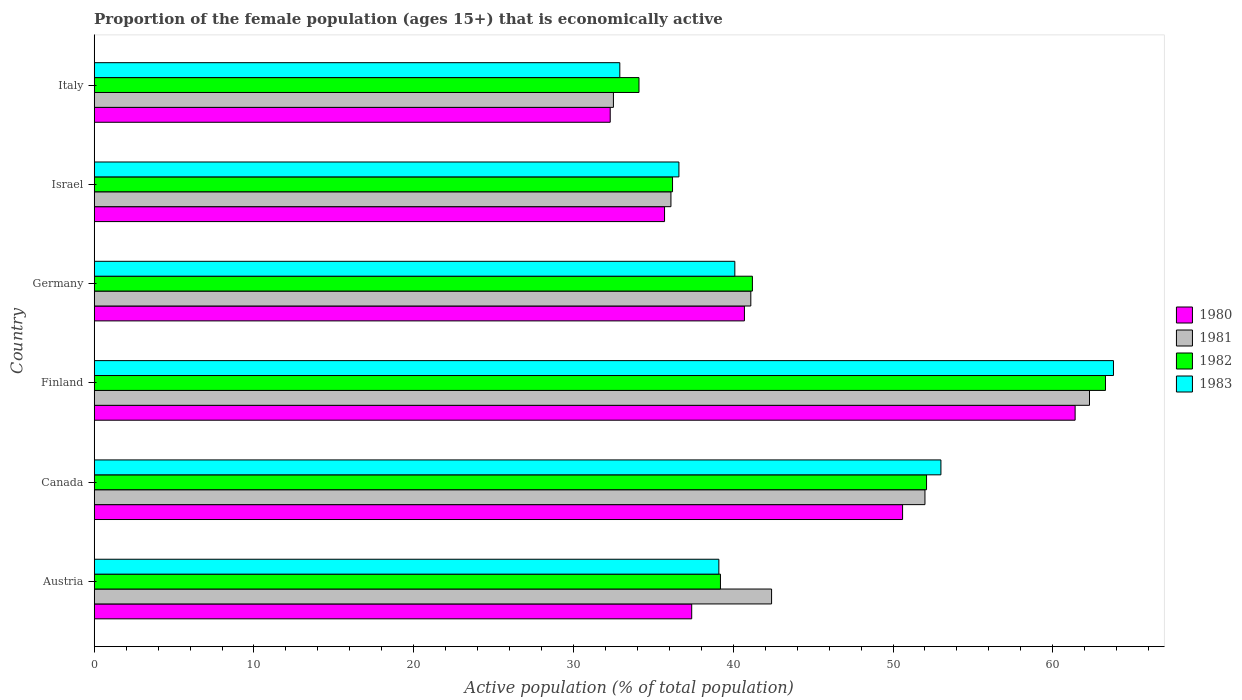How many different coloured bars are there?
Offer a terse response. 4. Are the number of bars per tick equal to the number of legend labels?
Offer a very short reply. Yes. How many bars are there on the 6th tick from the top?
Offer a terse response. 4. How many bars are there on the 6th tick from the bottom?
Your response must be concise. 4. What is the proportion of the female population that is economically active in 1981 in Israel?
Provide a short and direct response. 36.1. Across all countries, what is the maximum proportion of the female population that is economically active in 1983?
Your answer should be very brief. 63.8. Across all countries, what is the minimum proportion of the female population that is economically active in 1983?
Offer a terse response. 32.9. In which country was the proportion of the female population that is economically active in 1982 maximum?
Make the answer very short. Finland. In which country was the proportion of the female population that is economically active in 1982 minimum?
Ensure brevity in your answer.  Italy. What is the total proportion of the female population that is economically active in 1980 in the graph?
Give a very brief answer. 258.1. What is the difference between the proportion of the female population that is economically active in 1980 in Finland and that in Italy?
Ensure brevity in your answer.  29.1. What is the average proportion of the female population that is economically active in 1981 per country?
Your answer should be compact. 44.4. What is the difference between the proportion of the female population that is economically active in 1980 and proportion of the female population that is economically active in 1983 in Germany?
Your response must be concise. 0.6. What is the ratio of the proportion of the female population that is economically active in 1981 in Canada to that in Germany?
Provide a short and direct response. 1.27. What is the difference between the highest and the second highest proportion of the female population that is economically active in 1980?
Provide a succinct answer. 10.8. What is the difference between the highest and the lowest proportion of the female population that is economically active in 1980?
Offer a terse response. 29.1. Is the sum of the proportion of the female population that is economically active in 1983 in Austria and Germany greater than the maximum proportion of the female population that is economically active in 1981 across all countries?
Provide a short and direct response. Yes. Is it the case that in every country, the sum of the proportion of the female population that is economically active in 1981 and proportion of the female population that is economically active in 1983 is greater than the sum of proportion of the female population that is economically active in 1982 and proportion of the female population that is economically active in 1980?
Offer a terse response. No. What does the 3rd bar from the top in Israel represents?
Your response must be concise. 1981. What is the difference between two consecutive major ticks on the X-axis?
Keep it short and to the point. 10. Does the graph contain any zero values?
Provide a succinct answer. No. Where does the legend appear in the graph?
Ensure brevity in your answer.  Center right. How many legend labels are there?
Your answer should be very brief. 4. How are the legend labels stacked?
Your response must be concise. Vertical. What is the title of the graph?
Provide a succinct answer. Proportion of the female population (ages 15+) that is economically active. Does "1976" appear as one of the legend labels in the graph?
Offer a very short reply. No. What is the label or title of the X-axis?
Offer a terse response. Active population (% of total population). What is the Active population (% of total population) of 1980 in Austria?
Give a very brief answer. 37.4. What is the Active population (% of total population) in 1981 in Austria?
Offer a very short reply. 42.4. What is the Active population (% of total population) of 1982 in Austria?
Your answer should be very brief. 39.2. What is the Active population (% of total population) of 1983 in Austria?
Your response must be concise. 39.1. What is the Active population (% of total population) of 1980 in Canada?
Your answer should be very brief. 50.6. What is the Active population (% of total population) of 1982 in Canada?
Your response must be concise. 52.1. What is the Active population (% of total population) of 1980 in Finland?
Your response must be concise. 61.4. What is the Active population (% of total population) in 1981 in Finland?
Offer a terse response. 62.3. What is the Active population (% of total population) of 1982 in Finland?
Your answer should be very brief. 63.3. What is the Active population (% of total population) in 1983 in Finland?
Give a very brief answer. 63.8. What is the Active population (% of total population) of 1980 in Germany?
Offer a very short reply. 40.7. What is the Active population (% of total population) of 1981 in Germany?
Keep it short and to the point. 41.1. What is the Active population (% of total population) of 1982 in Germany?
Give a very brief answer. 41.2. What is the Active population (% of total population) in 1983 in Germany?
Offer a terse response. 40.1. What is the Active population (% of total population) in 1980 in Israel?
Provide a succinct answer. 35.7. What is the Active population (% of total population) of 1981 in Israel?
Give a very brief answer. 36.1. What is the Active population (% of total population) in 1982 in Israel?
Provide a succinct answer. 36.2. What is the Active population (% of total population) in 1983 in Israel?
Offer a terse response. 36.6. What is the Active population (% of total population) of 1980 in Italy?
Your answer should be very brief. 32.3. What is the Active population (% of total population) in 1981 in Italy?
Your answer should be compact. 32.5. What is the Active population (% of total population) in 1982 in Italy?
Provide a succinct answer. 34.1. What is the Active population (% of total population) in 1983 in Italy?
Offer a terse response. 32.9. Across all countries, what is the maximum Active population (% of total population) in 1980?
Give a very brief answer. 61.4. Across all countries, what is the maximum Active population (% of total population) of 1981?
Make the answer very short. 62.3. Across all countries, what is the maximum Active population (% of total population) of 1982?
Provide a succinct answer. 63.3. Across all countries, what is the maximum Active population (% of total population) in 1983?
Offer a terse response. 63.8. Across all countries, what is the minimum Active population (% of total population) in 1980?
Offer a terse response. 32.3. Across all countries, what is the minimum Active population (% of total population) of 1981?
Your response must be concise. 32.5. Across all countries, what is the minimum Active population (% of total population) of 1982?
Ensure brevity in your answer.  34.1. Across all countries, what is the minimum Active population (% of total population) in 1983?
Your answer should be compact. 32.9. What is the total Active population (% of total population) of 1980 in the graph?
Your answer should be compact. 258.1. What is the total Active population (% of total population) in 1981 in the graph?
Your answer should be very brief. 266.4. What is the total Active population (% of total population) in 1982 in the graph?
Your response must be concise. 266.1. What is the total Active population (% of total population) of 1983 in the graph?
Ensure brevity in your answer.  265.5. What is the difference between the Active population (% of total population) in 1981 in Austria and that in Canada?
Give a very brief answer. -9.6. What is the difference between the Active population (% of total population) of 1981 in Austria and that in Finland?
Your response must be concise. -19.9. What is the difference between the Active population (% of total population) in 1982 in Austria and that in Finland?
Your answer should be compact. -24.1. What is the difference between the Active population (% of total population) of 1983 in Austria and that in Finland?
Your response must be concise. -24.7. What is the difference between the Active population (% of total population) of 1980 in Austria and that in Israel?
Ensure brevity in your answer.  1.7. What is the difference between the Active population (% of total population) in 1983 in Austria and that in Israel?
Your answer should be compact. 2.5. What is the difference between the Active population (% of total population) in 1981 in Austria and that in Italy?
Ensure brevity in your answer.  9.9. What is the difference between the Active population (% of total population) of 1982 in Austria and that in Italy?
Provide a succinct answer. 5.1. What is the difference between the Active population (% of total population) in 1983 in Austria and that in Italy?
Offer a terse response. 6.2. What is the difference between the Active population (% of total population) of 1980 in Canada and that in Finland?
Provide a succinct answer. -10.8. What is the difference between the Active population (% of total population) in 1981 in Canada and that in Finland?
Provide a short and direct response. -10.3. What is the difference between the Active population (% of total population) in 1982 in Canada and that in Finland?
Provide a succinct answer. -11.2. What is the difference between the Active population (% of total population) of 1983 in Canada and that in Finland?
Ensure brevity in your answer.  -10.8. What is the difference between the Active population (% of total population) in 1982 in Canada and that in Germany?
Your answer should be very brief. 10.9. What is the difference between the Active population (% of total population) of 1980 in Canada and that in Israel?
Keep it short and to the point. 14.9. What is the difference between the Active population (% of total population) in 1983 in Canada and that in Israel?
Provide a succinct answer. 16.4. What is the difference between the Active population (% of total population) in 1980 in Canada and that in Italy?
Make the answer very short. 18.3. What is the difference between the Active population (% of total population) of 1982 in Canada and that in Italy?
Ensure brevity in your answer.  18. What is the difference between the Active population (% of total population) of 1983 in Canada and that in Italy?
Offer a terse response. 20.1. What is the difference between the Active population (% of total population) of 1980 in Finland and that in Germany?
Your answer should be compact. 20.7. What is the difference between the Active population (% of total population) in 1981 in Finland and that in Germany?
Offer a very short reply. 21.2. What is the difference between the Active population (% of total population) of 1982 in Finland and that in Germany?
Provide a succinct answer. 22.1. What is the difference between the Active population (% of total population) of 1983 in Finland and that in Germany?
Provide a succinct answer. 23.7. What is the difference between the Active population (% of total population) of 1980 in Finland and that in Israel?
Provide a short and direct response. 25.7. What is the difference between the Active population (% of total population) in 1981 in Finland and that in Israel?
Offer a very short reply. 26.2. What is the difference between the Active population (% of total population) of 1982 in Finland and that in Israel?
Ensure brevity in your answer.  27.1. What is the difference between the Active population (% of total population) in 1983 in Finland and that in Israel?
Provide a succinct answer. 27.2. What is the difference between the Active population (% of total population) in 1980 in Finland and that in Italy?
Your response must be concise. 29.1. What is the difference between the Active population (% of total population) of 1981 in Finland and that in Italy?
Offer a very short reply. 29.8. What is the difference between the Active population (% of total population) in 1982 in Finland and that in Italy?
Offer a very short reply. 29.2. What is the difference between the Active population (% of total population) in 1983 in Finland and that in Italy?
Make the answer very short. 30.9. What is the difference between the Active population (% of total population) in 1980 in Germany and that in Israel?
Your response must be concise. 5. What is the difference between the Active population (% of total population) of 1982 in Germany and that in Israel?
Ensure brevity in your answer.  5. What is the difference between the Active population (% of total population) in 1983 in Germany and that in Israel?
Provide a succinct answer. 3.5. What is the difference between the Active population (% of total population) of 1980 in Germany and that in Italy?
Your answer should be compact. 8.4. What is the difference between the Active population (% of total population) of 1981 in Germany and that in Italy?
Your answer should be very brief. 8.6. What is the difference between the Active population (% of total population) in 1983 in Germany and that in Italy?
Provide a succinct answer. 7.2. What is the difference between the Active population (% of total population) in 1980 in Israel and that in Italy?
Your answer should be very brief. 3.4. What is the difference between the Active population (% of total population) in 1982 in Israel and that in Italy?
Ensure brevity in your answer.  2.1. What is the difference between the Active population (% of total population) of 1980 in Austria and the Active population (% of total population) of 1981 in Canada?
Your response must be concise. -14.6. What is the difference between the Active population (% of total population) of 1980 in Austria and the Active population (% of total population) of 1982 in Canada?
Offer a very short reply. -14.7. What is the difference between the Active population (% of total population) of 1980 in Austria and the Active population (% of total population) of 1983 in Canada?
Your answer should be very brief. -15.6. What is the difference between the Active population (% of total population) in 1981 in Austria and the Active population (% of total population) in 1983 in Canada?
Provide a succinct answer. -10.6. What is the difference between the Active population (% of total population) of 1982 in Austria and the Active population (% of total population) of 1983 in Canada?
Offer a very short reply. -13.8. What is the difference between the Active population (% of total population) in 1980 in Austria and the Active population (% of total population) in 1981 in Finland?
Offer a very short reply. -24.9. What is the difference between the Active population (% of total population) of 1980 in Austria and the Active population (% of total population) of 1982 in Finland?
Offer a terse response. -25.9. What is the difference between the Active population (% of total population) in 1980 in Austria and the Active population (% of total population) in 1983 in Finland?
Provide a short and direct response. -26.4. What is the difference between the Active population (% of total population) in 1981 in Austria and the Active population (% of total population) in 1982 in Finland?
Provide a succinct answer. -20.9. What is the difference between the Active population (% of total population) of 1981 in Austria and the Active population (% of total population) of 1983 in Finland?
Keep it short and to the point. -21.4. What is the difference between the Active population (% of total population) of 1982 in Austria and the Active population (% of total population) of 1983 in Finland?
Your answer should be compact. -24.6. What is the difference between the Active population (% of total population) in 1980 in Austria and the Active population (% of total population) in 1982 in Germany?
Keep it short and to the point. -3.8. What is the difference between the Active population (% of total population) in 1981 in Austria and the Active population (% of total population) in 1982 in Germany?
Give a very brief answer. 1.2. What is the difference between the Active population (% of total population) in 1980 in Austria and the Active population (% of total population) in 1981 in Israel?
Give a very brief answer. 1.3. What is the difference between the Active population (% of total population) in 1980 in Austria and the Active population (% of total population) in 1983 in Israel?
Keep it short and to the point. 0.8. What is the difference between the Active population (% of total population) in 1981 in Austria and the Active population (% of total population) in 1982 in Israel?
Your response must be concise. 6.2. What is the difference between the Active population (% of total population) in 1982 in Austria and the Active population (% of total population) in 1983 in Israel?
Your answer should be compact. 2.6. What is the difference between the Active population (% of total population) in 1980 in Austria and the Active population (% of total population) in 1981 in Italy?
Provide a succinct answer. 4.9. What is the difference between the Active population (% of total population) of 1980 in Austria and the Active population (% of total population) of 1982 in Italy?
Ensure brevity in your answer.  3.3. What is the difference between the Active population (% of total population) of 1980 in Austria and the Active population (% of total population) of 1983 in Italy?
Provide a short and direct response. 4.5. What is the difference between the Active population (% of total population) of 1981 in Canada and the Active population (% of total population) of 1983 in Finland?
Make the answer very short. -11.8. What is the difference between the Active population (% of total population) of 1982 in Canada and the Active population (% of total population) of 1983 in Finland?
Give a very brief answer. -11.7. What is the difference between the Active population (% of total population) of 1980 in Canada and the Active population (% of total population) of 1981 in Germany?
Give a very brief answer. 9.5. What is the difference between the Active population (% of total population) in 1981 in Canada and the Active population (% of total population) in 1982 in Germany?
Your response must be concise. 10.8. What is the difference between the Active population (% of total population) in 1982 in Canada and the Active population (% of total population) in 1983 in Germany?
Your answer should be very brief. 12. What is the difference between the Active population (% of total population) of 1980 in Canada and the Active population (% of total population) of 1981 in Israel?
Keep it short and to the point. 14.5. What is the difference between the Active population (% of total population) of 1980 in Canada and the Active population (% of total population) of 1982 in Israel?
Offer a terse response. 14.4. What is the difference between the Active population (% of total population) of 1980 in Canada and the Active population (% of total population) of 1983 in Israel?
Make the answer very short. 14. What is the difference between the Active population (% of total population) in 1981 in Canada and the Active population (% of total population) in 1982 in Israel?
Give a very brief answer. 15.8. What is the difference between the Active population (% of total population) of 1982 in Canada and the Active population (% of total population) of 1983 in Israel?
Offer a very short reply. 15.5. What is the difference between the Active population (% of total population) of 1980 in Canada and the Active population (% of total population) of 1982 in Italy?
Your response must be concise. 16.5. What is the difference between the Active population (% of total population) in 1980 in Canada and the Active population (% of total population) in 1983 in Italy?
Keep it short and to the point. 17.7. What is the difference between the Active population (% of total population) in 1980 in Finland and the Active population (% of total population) in 1981 in Germany?
Your answer should be compact. 20.3. What is the difference between the Active population (% of total population) of 1980 in Finland and the Active population (% of total population) of 1982 in Germany?
Your answer should be compact. 20.2. What is the difference between the Active population (% of total population) of 1980 in Finland and the Active population (% of total population) of 1983 in Germany?
Your answer should be very brief. 21.3. What is the difference between the Active population (% of total population) of 1981 in Finland and the Active population (% of total population) of 1982 in Germany?
Provide a succinct answer. 21.1. What is the difference between the Active population (% of total population) in 1981 in Finland and the Active population (% of total population) in 1983 in Germany?
Make the answer very short. 22.2. What is the difference between the Active population (% of total population) of 1982 in Finland and the Active population (% of total population) of 1983 in Germany?
Make the answer very short. 23.2. What is the difference between the Active population (% of total population) of 1980 in Finland and the Active population (% of total population) of 1981 in Israel?
Give a very brief answer. 25.3. What is the difference between the Active population (% of total population) in 1980 in Finland and the Active population (% of total population) in 1982 in Israel?
Give a very brief answer. 25.2. What is the difference between the Active population (% of total population) of 1980 in Finland and the Active population (% of total population) of 1983 in Israel?
Provide a short and direct response. 24.8. What is the difference between the Active population (% of total population) of 1981 in Finland and the Active population (% of total population) of 1982 in Israel?
Provide a short and direct response. 26.1. What is the difference between the Active population (% of total population) of 1981 in Finland and the Active population (% of total population) of 1983 in Israel?
Keep it short and to the point. 25.7. What is the difference between the Active population (% of total population) of 1982 in Finland and the Active population (% of total population) of 1983 in Israel?
Ensure brevity in your answer.  26.7. What is the difference between the Active population (% of total population) of 1980 in Finland and the Active population (% of total population) of 1981 in Italy?
Keep it short and to the point. 28.9. What is the difference between the Active population (% of total population) in 1980 in Finland and the Active population (% of total population) in 1982 in Italy?
Provide a short and direct response. 27.3. What is the difference between the Active population (% of total population) in 1980 in Finland and the Active population (% of total population) in 1983 in Italy?
Your response must be concise. 28.5. What is the difference between the Active population (% of total population) in 1981 in Finland and the Active population (% of total population) in 1982 in Italy?
Ensure brevity in your answer.  28.2. What is the difference between the Active population (% of total population) in 1981 in Finland and the Active population (% of total population) in 1983 in Italy?
Your answer should be compact. 29.4. What is the difference between the Active population (% of total population) in 1982 in Finland and the Active population (% of total population) in 1983 in Italy?
Ensure brevity in your answer.  30.4. What is the difference between the Active population (% of total population) in 1980 in Germany and the Active population (% of total population) in 1983 in Israel?
Offer a terse response. 4.1. What is the difference between the Active population (% of total population) in 1981 in Germany and the Active population (% of total population) in 1983 in Israel?
Provide a short and direct response. 4.5. What is the difference between the Active population (% of total population) in 1982 in Germany and the Active population (% of total population) in 1983 in Israel?
Offer a terse response. 4.6. What is the difference between the Active population (% of total population) in 1980 in Germany and the Active population (% of total population) in 1981 in Italy?
Your answer should be compact. 8.2. What is the difference between the Active population (% of total population) in 1980 in Israel and the Active population (% of total population) in 1981 in Italy?
Provide a succinct answer. 3.2. What is the difference between the Active population (% of total population) of 1980 in Israel and the Active population (% of total population) of 1982 in Italy?
Your response must be concise. 1.6. What is the difference between the Active population (% of total population) in 1981 in Israel and the Active population (% of total population) in 1982 in Italy?
Provide a short and direct response. 2. What is the difference between the Active population (% of total population) of 1981 in Israel and the Active population (% of total population) of 1983 in Italy?
Your answer should be very brief. 3.2. What is the difference between the Active population (% of total population) in 1982 in Israel and the Active population (% of total population) in 1983 in Italy?
Your answer should be compact. 3.3. What is the average Active population (% of total population) in 1980 per country?
Your response must be concise. 43.02. What is the average Active population (% of total population) in 1981 per country?
Ensure brevity in your answer.  44.4. What is the average Active population (% of total population) in 1982 per country?
Your response must be concise. 44.35. What is the average Active population (% of total population) in 1983 per country?
Your answer should be compact. 44.25. What is the difference between the Active population (% of total population) of 1981 and Active population (% of total population) of 1983 in Austria?
Provide a succinct answer. 3.3. What is the difference between the Active population (% of total population) of 1981 and Active population (% of total population) of 1982 in Canada?
Provide a succinct answer. -0.1. What is the difference between the Active population (% of total population) of 1981 and Active population (% of total population) of 1983 in Canada?
Your response must be concise. -1. What is the difference between the Active population (% of total population) in 1980 and Active population (% of total population) in 1982 in Finland?
Your response must be concise. -1.9. What is the difference between the Active population (% of total population) in 1980 and Active population (% of total population) in 1983 in Finland?
Offer a very short reply. -2.4. What is the difference between the Active population (% of total population) of 1981 and Active population (% of total population) of 1982 in Finland?
Make the answer very short. -1. What is the difference between the Active population (% of total population) of 1981 and Active population (% of total population) of 1983 in Finland?
Provide a succinct answer. -1.5. What is the difference between the Active population (% of total population) of 1980 and Active population (% of total population) of 1981 in Germany?
Offer a terse response. -0.4. What is the difference between the Active population (% of total population) of 1980 and Active population (% of total population) of 1983 in Germany?
Make the answer very short. 0.6. What is the difference between the Active population (% of total population) of 1981 and Active population (% of total population) of 1982 in Germany?
Make the answer very short. -0.1. What is the difference between the Active population (% of total population) of 1980 and Active population (% of total population) of 1983 in Israel?
Ensure brevity in your answer.  -0.9. What is the difference between the Active population (% of total population) of 1981 and Active population (% of total population) of 1982 in Israel?
Give a very brief answer. -0.1. What is the difference between the Active population (% of total population) of 1981 and Active population (% of total population) of 1983 in Israel?
Keep it short and to the point. -0.5. What is the difference between the Active population (% of total population) in 1982 and Active population (% of total population) in 1983 in Israel?
Provide a succinct answer. -0.4. What is the difference between the Active population (% of total population) of 1980 and Active population (% of total population) of 1982 in Italy?
Give a very brief answer. -1.8. What is the difference between the Active population (% of total population) in 1981 and Active population (% of total population) in 1983 in Italy?
Your answer should be compact. -0.4. What is the difference between the Active population (% of total population) of 1982 and Active population (% of total population) of 1983 in Italy?
Provide a short and direct response. 1.2. What is the ratio of the Active population (% of total population) of 1980 in Austria to that in Canada?
Provide a short and direct response. 0.74. What is the ratio of the Active population (% of total population) in 1981 in Austria to that in Canada?
Provide a succinct answer. 0.82. What is the ratio of the Active population (% of total population) of 1982 in Austria to that in Canada?
Offer a terse response. 0.75. What is the ratio of the Active population (% of total population) in 1983 in Austria to that in Canada?
Ensure brevity in your answer.  0.74. What is the ratio of the Active population (% of total population) of 1980 in Austria to that in Finland?
Make the answer very short. 0.61. What is the ratio of the Active population (% of total population) of 1981 in Austria to that in Finland?
Your response must be concise. 0.68. What is the ratio of the Active population (% of total population) in 1982 in Austria to that in Finland?
Your answer should be very brief. 0.62. What is the ratio of the Active population (% of total population) in 1983 in Austria to that in Finland?
Provide a short and direct response. 0.61. What is the ratio of the Active population (% of total population) in 1980 in Austria to that in Germany?
Offer a terse response. 0.92. What is the ratio of the Active population (% of total population) of 1981 in Austria to that in Germany?
Your response must be concise. 1.03. What is the ratio of the Active population (% of total population) in 1982 in Austria to that in Germany?
Provide a short and direct response. 0.95. What is the ratio of the Active population (% of total population) of 1983 in Austria to that in Germany?
Your answer should be very brief. 0.98. What is the ratio of the Active population (% of total population) of 1980 in Austria to that in Israel?
Your answer should be very brief. 1.05. What is the ratio of the Active population (% of total population) in 1981 in Austria to that in Israel?
Offer a very short reply. 1.17. What is the ratio of the Active population (% of total population) of 1982 in Austria to that in Israel?
Your response must be concise. 1.08. What is the ratio of the Active population (% of total population) of 1983 in Austria to that in Israel?
Provide a succinct answer. 1.07. What is the ratio of the Active population (% of total population) in 1980 in Austria to that in Italy?
Offer a terse response. 1.16. What is the ratio of the Active population (% of total population) in 1981 in Austria to that in Italy?
Provide a short and direct response. 1.3. What is the ratio of the Active population (% of total population) in 1982 in Austria to that in Italy?
Provide a succinct answer. 1.15. What is the ratio of the Active population (% of total population) of 1983 in Austria to that in Italy?
Your answer should be compact. 1.19. What is the ratio of the Active population (% of total population) of 1980 in Canada to that in Finland?
Ensure brevity in your answer.  0.82. What is the ratio of the Active population (% of total population) of 1981 in Canada to that in Finland?
Your answer should be compact. 0.83. What is the ratio of the Active population (% of total population) in 1982 in Canada to that in Finland?
Your response must be concise. 0.82. What is the ratio of the Active population (% of total population) in 1983 in Canada to that in Finland?
Offer a terse response. 0.83. What is the ratio of the Active population (% of total population) in 1980 in Canada to that in Germany?
Provide a short and direct response. 1.24. What is the ratio of the Active population (% of total population) of 1981 in Canada to that in Germany?
Your answer should be compact. 1.27. What is the ratio of the Active population (% of total population) in 1982 in Canada to that in Germany?
Offer a very short reply. 1.26. What is the ratio of the Active population (% of total population) in 1983 in Canada to that in Germany?
Make the answer very short. 1.32. What is the ratio of the Active population (% of total population) of 1980 in Canada to that in Israel?
Keep it short and to the point. 1.42. What is the ratio of the Active population (% of total population) in 1981 in Canada to that in Israel?
Make the answer very short. 1.44. What is the ratio of the Active population (% of total population) of 1982 in Canada to that in Israel?
Your response must be concise. 1.44. What is the ratio of the Active population (% of total population) in 1983 in Canada to that in Israel?
Make the answer very short. 1.45. What is the ratio of the Active population (% of total population) of 1980 in Canada to that in Italy?
Provide a short and direct response. 1.57. What is the ratio of the Active population (% of total population) in 1981 in Canada to that in Italy?
Your answer should be compact. 1.6. What is the ratio of the Active population (% of total population) in 1982 in Canada to that in Italy?
Ensure brevity in your answer.  1.53. What is the ratio of the Active population (% of total population) of 1983 in Canada to that in Italy?
Provide a succinct answer. 1.61. What is the ratio of the Active population (% of total population) of 1980 in Finland to that in Germany?
Your answer should be compact. 1.51. What is the ratio of the Active population (% of total population) of 1981 in Finland to that in Germany?
Provide a short and direct response. 1.52. What is the ratio of the Active population (% of total population) of 1982 in Finland to that in Germany?
Offer a very short reply. 1.54. What is the ratio of the Active population (% of total population) of 1983 in Finland to that in Germany?
Your answer should be very brief. 1.59. What is the ratio of the Active population (% of total population) of 1980 in Finland to that in Israel?
Offer a terse response. 1.72. What is the ratio of the Active population (% of total population) of 1981 in Finland to that in Israel?
Your response must be concise. 1.73. What is the ratio of the Active population (% of total population) in 1982 in Finland to that in Israel?
Ensure brevity in your answer.  1.75. What is the ratio of the Active population (% of total population) of 1983 in Finland to that in Israel?
Give a very brief answer. 1.74. What is the ratio of the Active population (% of total population) in 1980 in Finland to that in Italy?
Provide a short and direct response. 1.9. What is the ratio of the Active population (% of total population) in 1981 in Finland to that in Italy?
Your answer should be very brief. 1.92. What is the ratio of the Active population (% of total population) of 1982 in Finland to that in Italy?
Provide a short and direct response. 1.86. What is the ratio of the Active population (% of total population) in 1983 in Finland to that in Italy?
Your answer should be compact. 1.94. What is the ratio of the Active population (% of total population) of 1980 in Germany to that in Israel?
Provide a succinct answer. 1.14. What is the ratio of the Active population (% of total population) in 1981 in Germany to that in Israel?
Give a very brief answer. 1.14. What is the ratio of the Active population (% of total population) of 1982 in Germany to that in Israel?
Make the answer very short. 1.14. What is the ratio of the Active population (% of total population) of 1983 in Germany to that in Israel?
Provide a succinct answer. 1.1. What is the ratio of the Active population (% of total population) in 1980 in Germany to that in Italy?
Give a very brief answer. 1.26. What is the ratio of the Active population (% of total population) of 1981 in Germany to that in Italy?
Your answer should be compact. 1.26. What is the ratio of the Active population (% of total population) of 1982 in Germany to that in Italy?
Offer a very short reply. 1.21. What is the ratio of the Active population (% of total population) in 1983 in Germany to that in Italy?
Your answer should be compact. 1.22. What is the ratio of the Active population (% of total population) of 1980 in Israel to that in Italy?
Give a very brief answer. 1.11. What is the ratio of the Active population (% of total population) in 1981 in Israel to that in Italy?
Keep it short and to the point. 1.11. What is the ratio of the Active population (% of total population) of 1982 in Israel to that in Italy?
Make the answer very short. 1.06. What is the ratio of the Active population (% of total population) in 1983 in Israel to that in Italy?
Your answer should be very brief. 1.11. What is the difference between the highest and the second highest Active population (% of total population) of 1980?
Provide a succinct answer. 10.8. What is the difference between the highest and the second highest Active population (% of total population) of 1982?
Your answer should be very brief. 11.2. What is the difference between the highest and the lowest Active population (% of total population) in 1980?
Ensure brevity in your answer.  29.1. What is the difference between the highest and the lowest Active population (% of total population) of 1981?
Offer a very short reply. 29.8. What is the difference between the highest and the lowest Active population (% of total population) in 1982?
Make the answer very short. 29.2. What is the difference between the highest and the lowest Active population (% of total population) in 1983?
Ensure brevity in your answer.  30.9. 